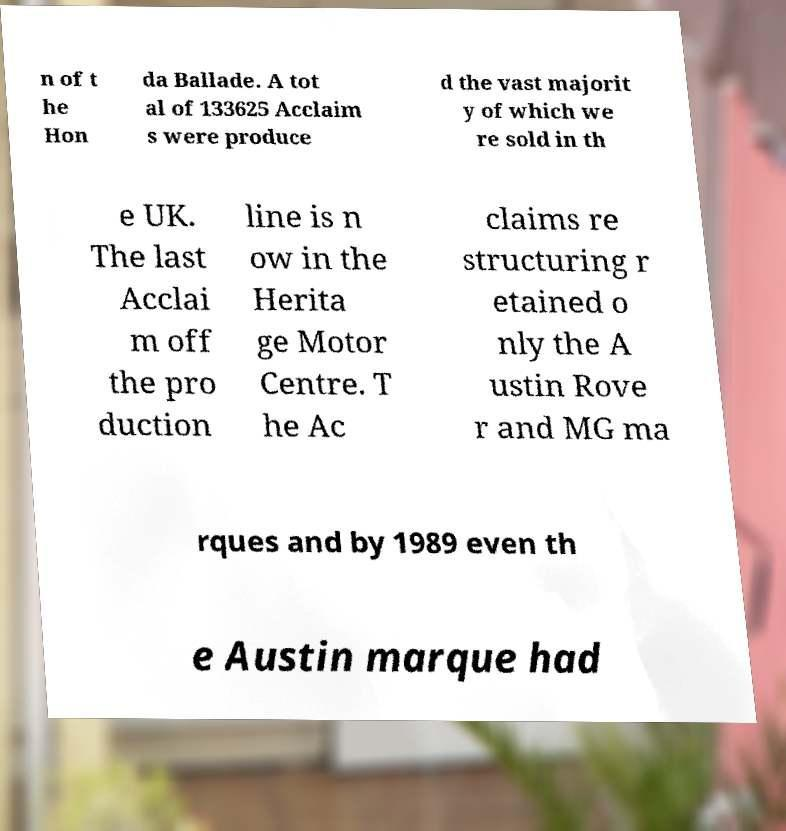Please identify and transcribe the text found in this image. n of t he Hon da Ballade. A tot al of 133625 Acclaim s were produce d the vast majorit y of which we re sold in th e UK. The last Acclai m off the pro duction line is n ow in the Herita ge Motor Centre. T he Ac claims re structuring r etained o nly the A ustin Rove r and MG ma rques and by 1989 even th e Austin marque had 